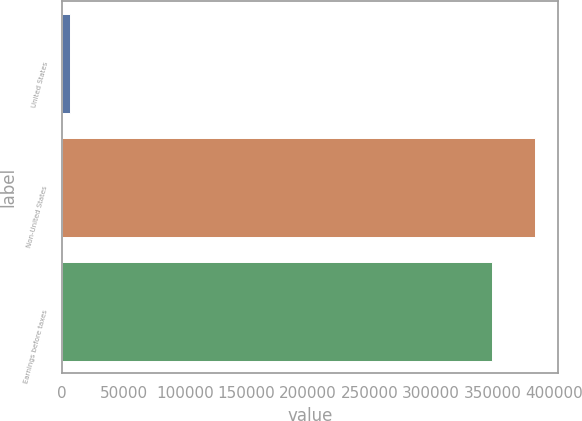Convert chart. <chart><loc_0><loc_0><loc_500><loc_500><bar_chart><fcel>United States<fcel>Non-United States<fcel>Earnings before taxes<nl><fcel>6758<fcel>384095<fcel>349177<nl></chart> 